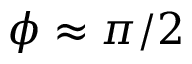Convert formula to latex. <formula><loc_0><loc_0><loc_500><loc_500>\phi \approx \pi / 2</formula> 